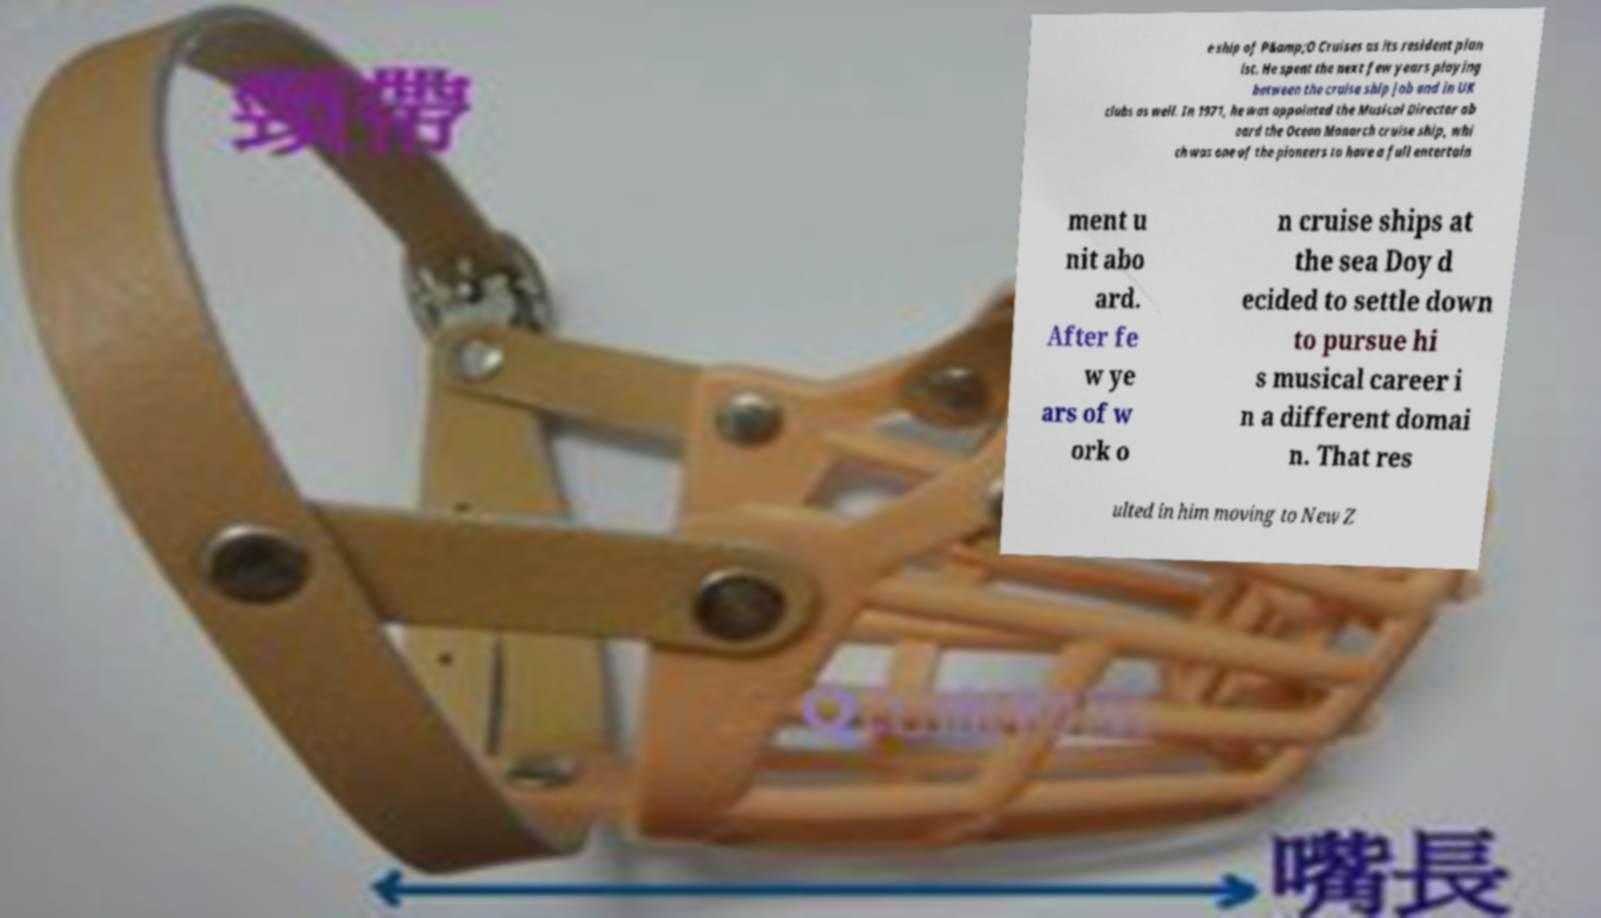Can you read and provide the text displayed in the image?This photo seems to have some interesting text. Can you extract and type it out for me? e ship of P&amp;O Cruises as its resident pian ist. He spent the next few years playing between the cruise ship job and in UK clubs as well. In 1971, he was appointed the Musical Director ab oard the Ocean Monarch cruise ship, whi ch was one of the pioneers to have a full entertain ment u nit abo ard. After fe w ye ars of w ork o n cruise ships at the sea Doy d ecided to settle down to pursue hi s musical career i n a different domai n. That res ulted in him moving to New Z 